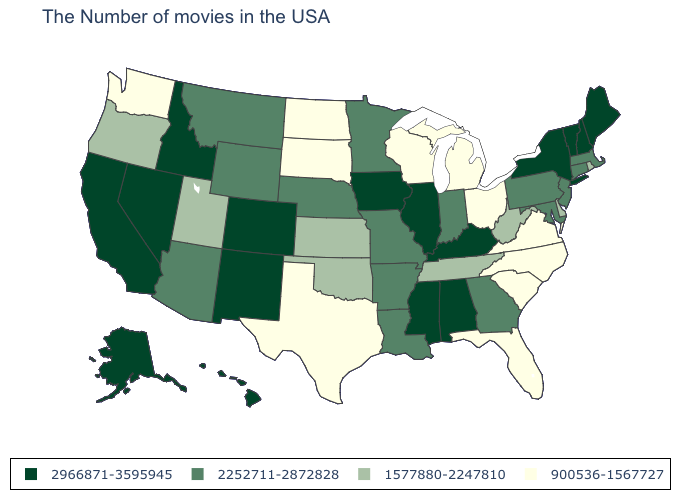What is the lowest value in the USA?
Quick response, please. 900536-1567727. Name the states that have a value in the range 900536-1567727?
Give a very brief answer. Virginia, North Carolina, South Carolina, Ohio, Florida, Michigan, Wisconsin, Texas, South Dakota, North Dakota, Washington. Does the first symbol in the legend represent the smallest category?
Write a very short answer. No. Among the states that border Texas , which have the lowest value?
Short answer required. Oklahoma. What is the value of Alabama?
Write a very short answer. 2966871-3595945. Which states have the lowest value in the Northeast?
Keep it brief. Rhode Island. What is the value of California?
Quick response, please. 2966871-3595945. What is the value of Wisconsin?
Write a very short answer. 900536-1567727. Name the states that have a value in the range 900536-1567727?
Keep it brief. Virginia, North Carolina, South Carolina, Ohio, Florida, Michigan, Wisconsin, Texas, South Dakota, North Dakota, Washington. What is the value of New Jersey?
Give a very brief answer. 2252711-2872828. Name the states that have a value in the range 900536-1567727?
Write a very short answer. Virginia, North Carolina, South Carolina, Ohio, Florida, Michigan, Wisconsin, Texas, South Dakota, North Dakota, Washington. Does Utah have a higher value than Washington?
Concise answer only. Yes. What is the highest value in the MidWest ?
Short answer required. 2966871-3595945. Which states hav the highest value in the West?
Be succinct. Colorado, New Mexico, Idaho, Nevada, California, Alaska, Hawaii. Which states hav the highest value in the MidWest?
Keep it brief. Illinois, Iowa. 